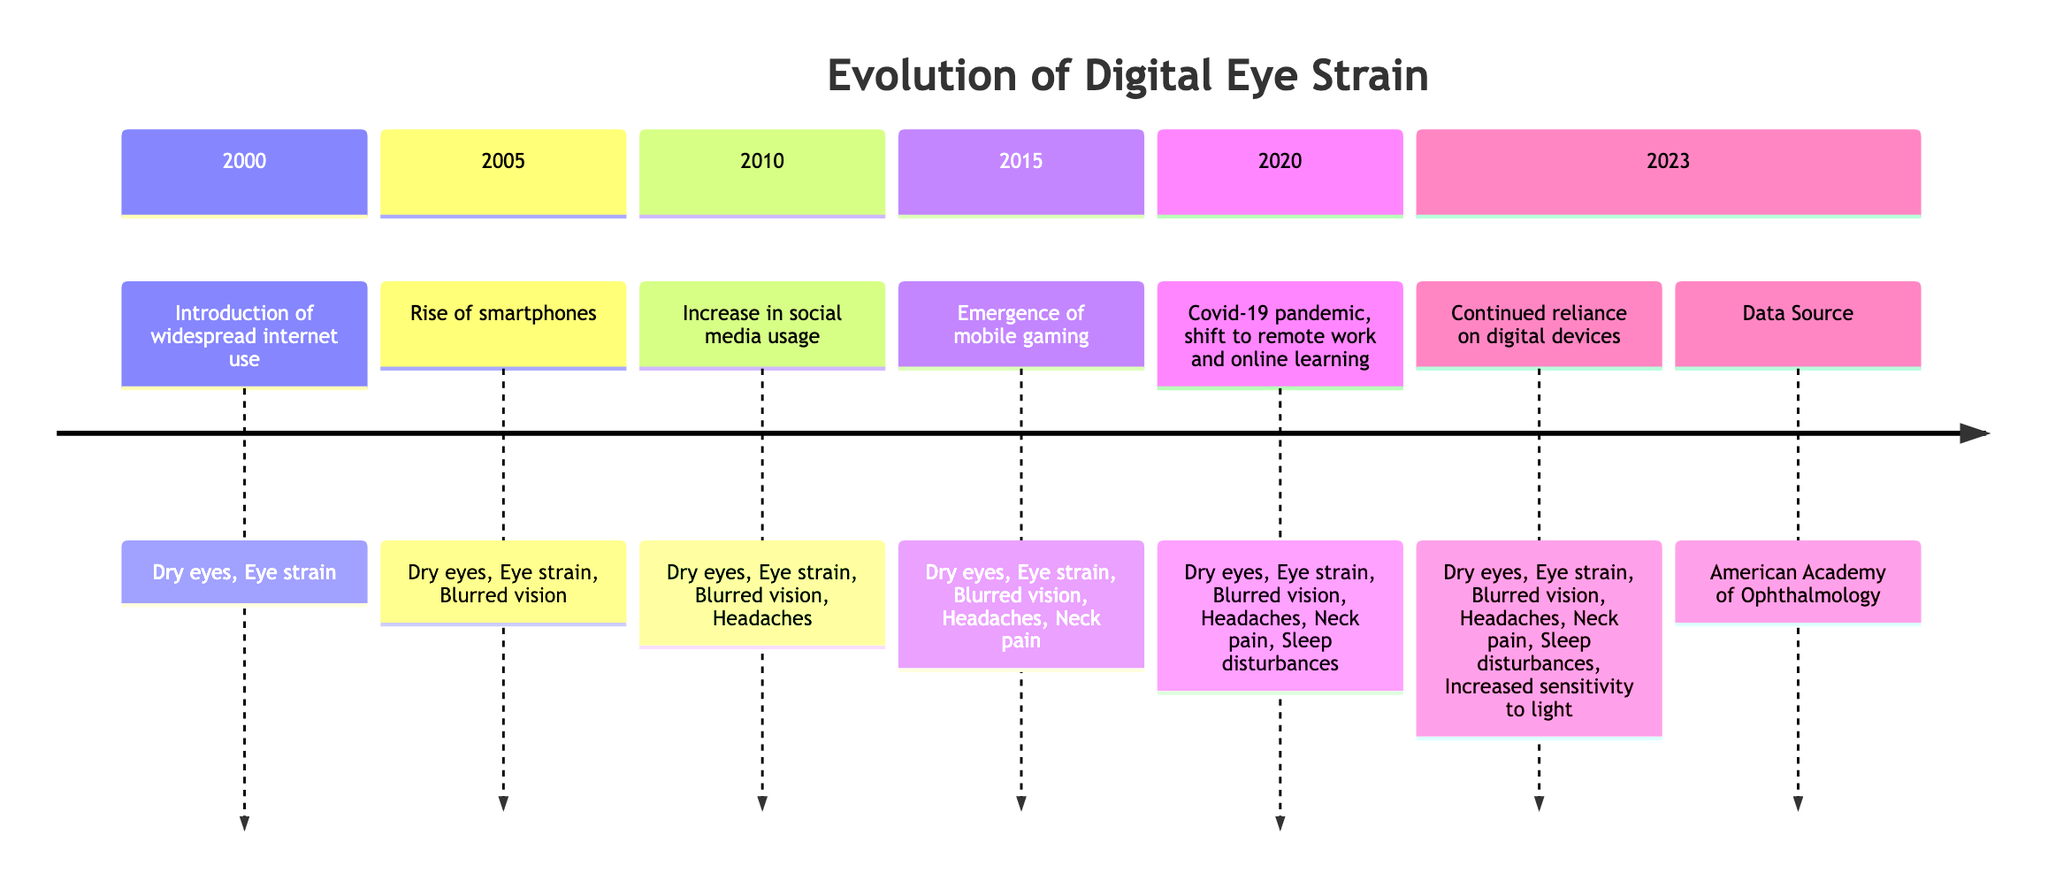What year marks the introduction of widespread internet use? The diagram indicates that the introduction of widespread internet use occurred in the year 2000. This is directly stated in the section for 2000 of the timeline.
Answer: 2000 Which symptom was first reported in 2000? According to the timeline, dry eyes and eye strain were the symptoms reported in 2000. Since the question asks for the first symptom reported, we can focus on the first listed symptom in that section.
Answer: Dry eyes How many symptoms are associated with the year 2020? Reviewing the section for the year 2020, the diagram lists six symptoms: dry eyes, eye strain, blurred vision, headaches, neck pain, and sleep disturbances. Counting these symptoms gives a total of six.
Answer: 6 What significant event coincided with the increase of symptoms in 2020? The timeline specifies that the Covid-19 pandemic, along with the shift to remote work and online learning, was the significant event in 2020 that led to an increase in symptoms. This event is directly mentioned in that section of the diagram.
Answer: Covid-19 pandemic Which year saw the rise of smartphones and what symptoms were associated with that year? The year 2005 is noted for the rise of smartphones, with the associated symptoms being dry eyes, eye strain, and blurred vision. This information is explicitly stated in the section for 2005.
Answer: 2005: Dry eyes, Eye strain, Blurred vision What new symptom appeared in 2023 that was not present in 2005? Analyzing the sections of the timeline shows that “increased sensitivity to light” is the new symptom reported in 2023, which is not listed for 2005. This requires examining the 2005 and 2023 sections to see the differences in symptoms.
Answer: Increased sensitivity to light What is the trend observed in the number of symptoms from 2000 to 2023? By examining the timeline, we can see that the number of symptoms is increasing with each passing year, beginning with two symptoms in 2000 and reaching eight in 2023. The increasing count reflects a growing concern over digital eye strain.
Answer: Increasing Which section has the most symptoms listed? The section for 2023 has the most symptoms listed, with a total of seven symptoms. Comparing the symptom lists from each year, 2023 has the highest count, indicating a significant rise in reported symptoms associated with digital eye strain.
Answer: 2023 What commonality is present in the symptoms across all years? By reviewing the symptoms listed for every year, dry eyes and eye strain are the only symptoms present in each of the years from 2000 to 2023. This suggests these symptoms are consistently associated with prolonged screen time.
Answer: Dry eyes, Eye strain 